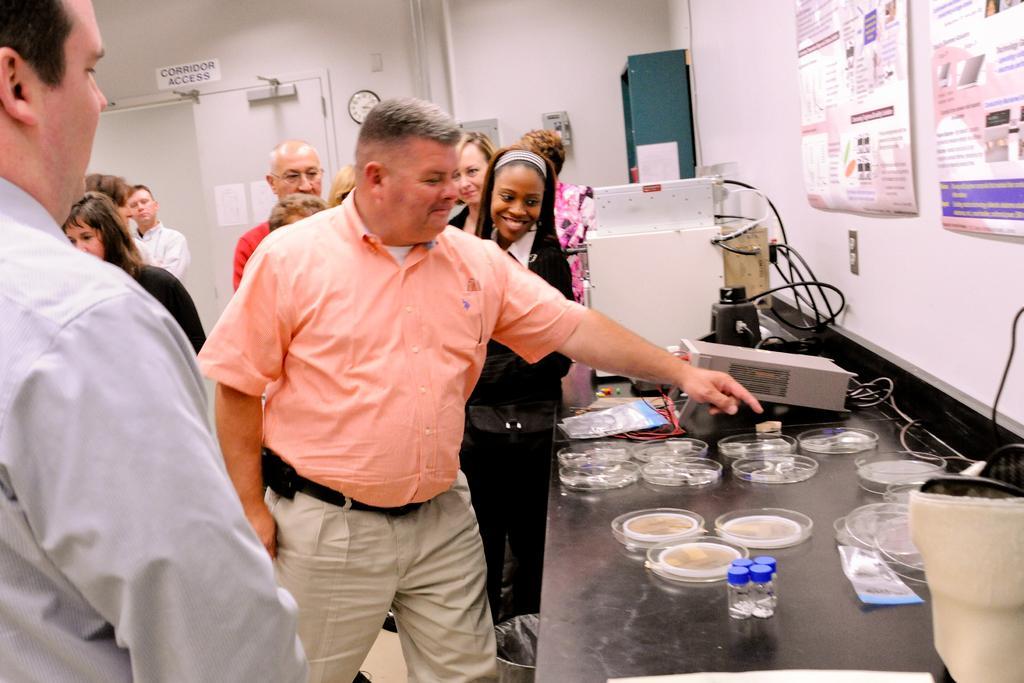Please provide a concise description of this image. On the left side of the image there are people, door, posters, board and clock. Posters are on the door. Board and clock are on the wall. On the right side of the image there is a platform, bed, rack, posters, equipment, cables and objects. Posters are on the wall. Equipment, cable and objects are on the platform.   